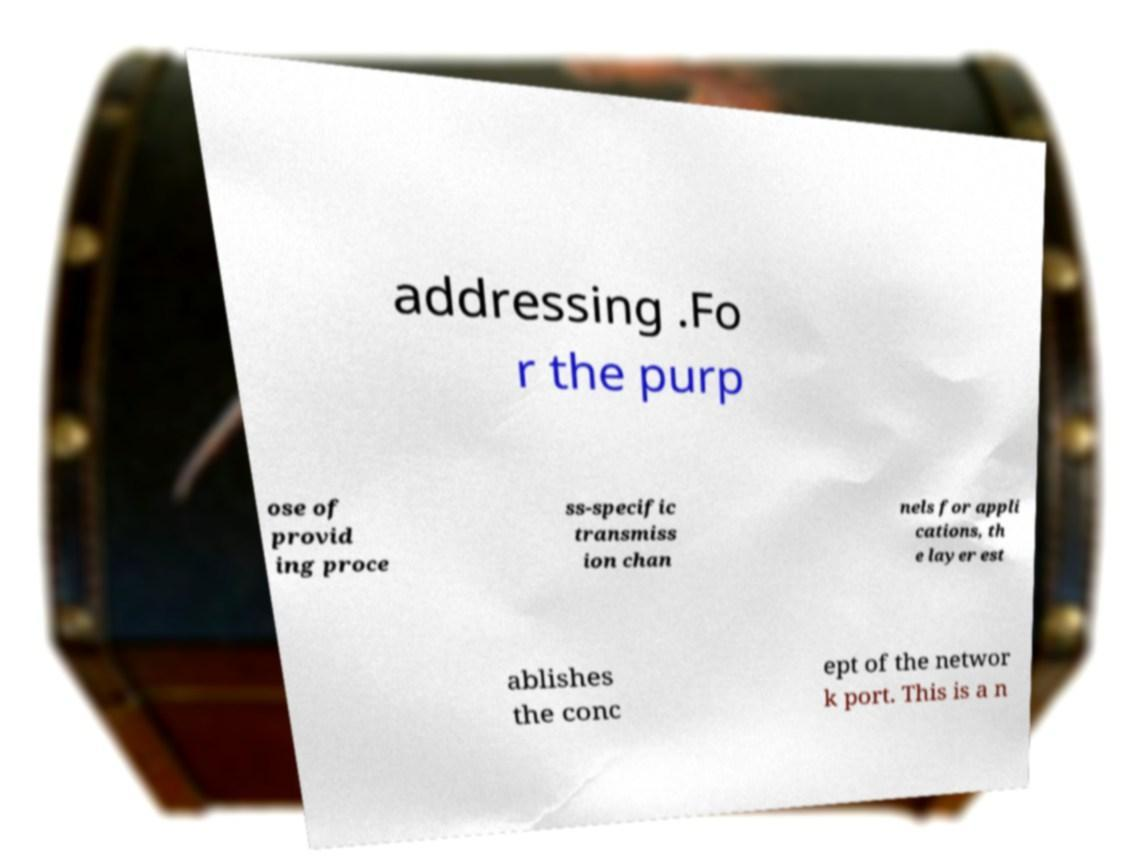For documentation purposes, I need the text within this image transcribed. Could you provide that? addressing .Fo r the purp ose of provid ing proce ss-specific transmiss ion chan nels for appli cations, th e layer est ablishes the conc ept of the networ k port. This is a n 